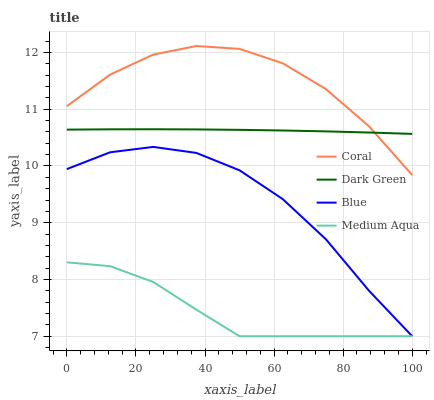Does Medium Aqua have the minimum area under the curve?
Answer yes or no. Yes. Does Coral have the maximum area under the curve?
Answer yes or no. Yes. Does Coral have the minimum area under the curve?
Answer yes or no. No. Does Medium Aqua have the maximum area under the curve?
Answer yes or no. No. Is Dark Green the smoothest?
Answer yes or no. Yes. Is Coral the roughest?
Answer yes or no. Yes. Is Medium Aqua the smoothest?
Answer yes or no. No. Is Medium Aqua the roughest?
Answer yes or no. No. Does Blue have the lowest value?
Answer yes or no. Yes. Does Coral have the lowest value?
Answer yes or no. No. Does Coral have the highest value?
Answer yes or no. Yes. Does Medium Aqua have the highest value?
Answer yes or no. No. Is Medium Aqua less than Coral?
Answer yes or no. Yes. Is Coral greater than Medium Aqua?
Answer yes or no. Yes. Does Dark Green intersect Coral?
Answer yes or no. Yes. Is Dark Green less than Coral?
Answer yes or no. No. Is Dark Green greater than Coral?
Answer yes or no. No. Does Medium Aqua intersect Coral?
Answer yes or no. No. 